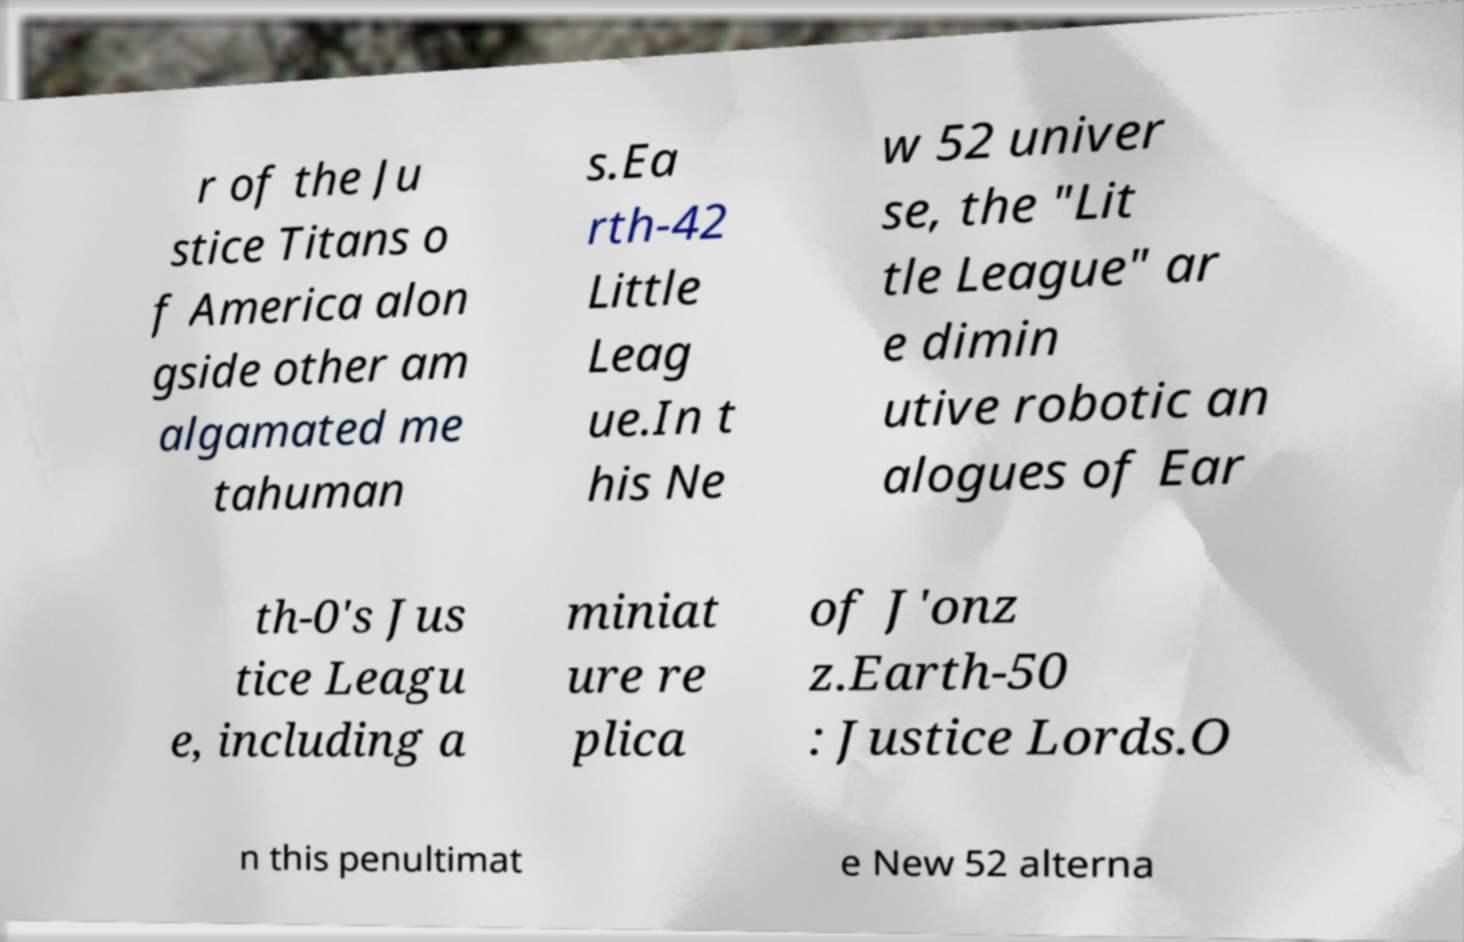For documentation purposes, I need the text within this image transcribed. Could you provide that? r of the Ju stice Titans o f America alon gside other am algamated me tahuman s.Ea rth-42 Little Leag ue.In t his Ne w 52 univer se, the "Lit tle League" ar e dimin utive robotic an alogues of Ear th-0's Jus tice Leagu e, including a miniat ure re plica of J'onz z.Earth-50 : Justice Lords.O n this penultimat e New 52 alterna 